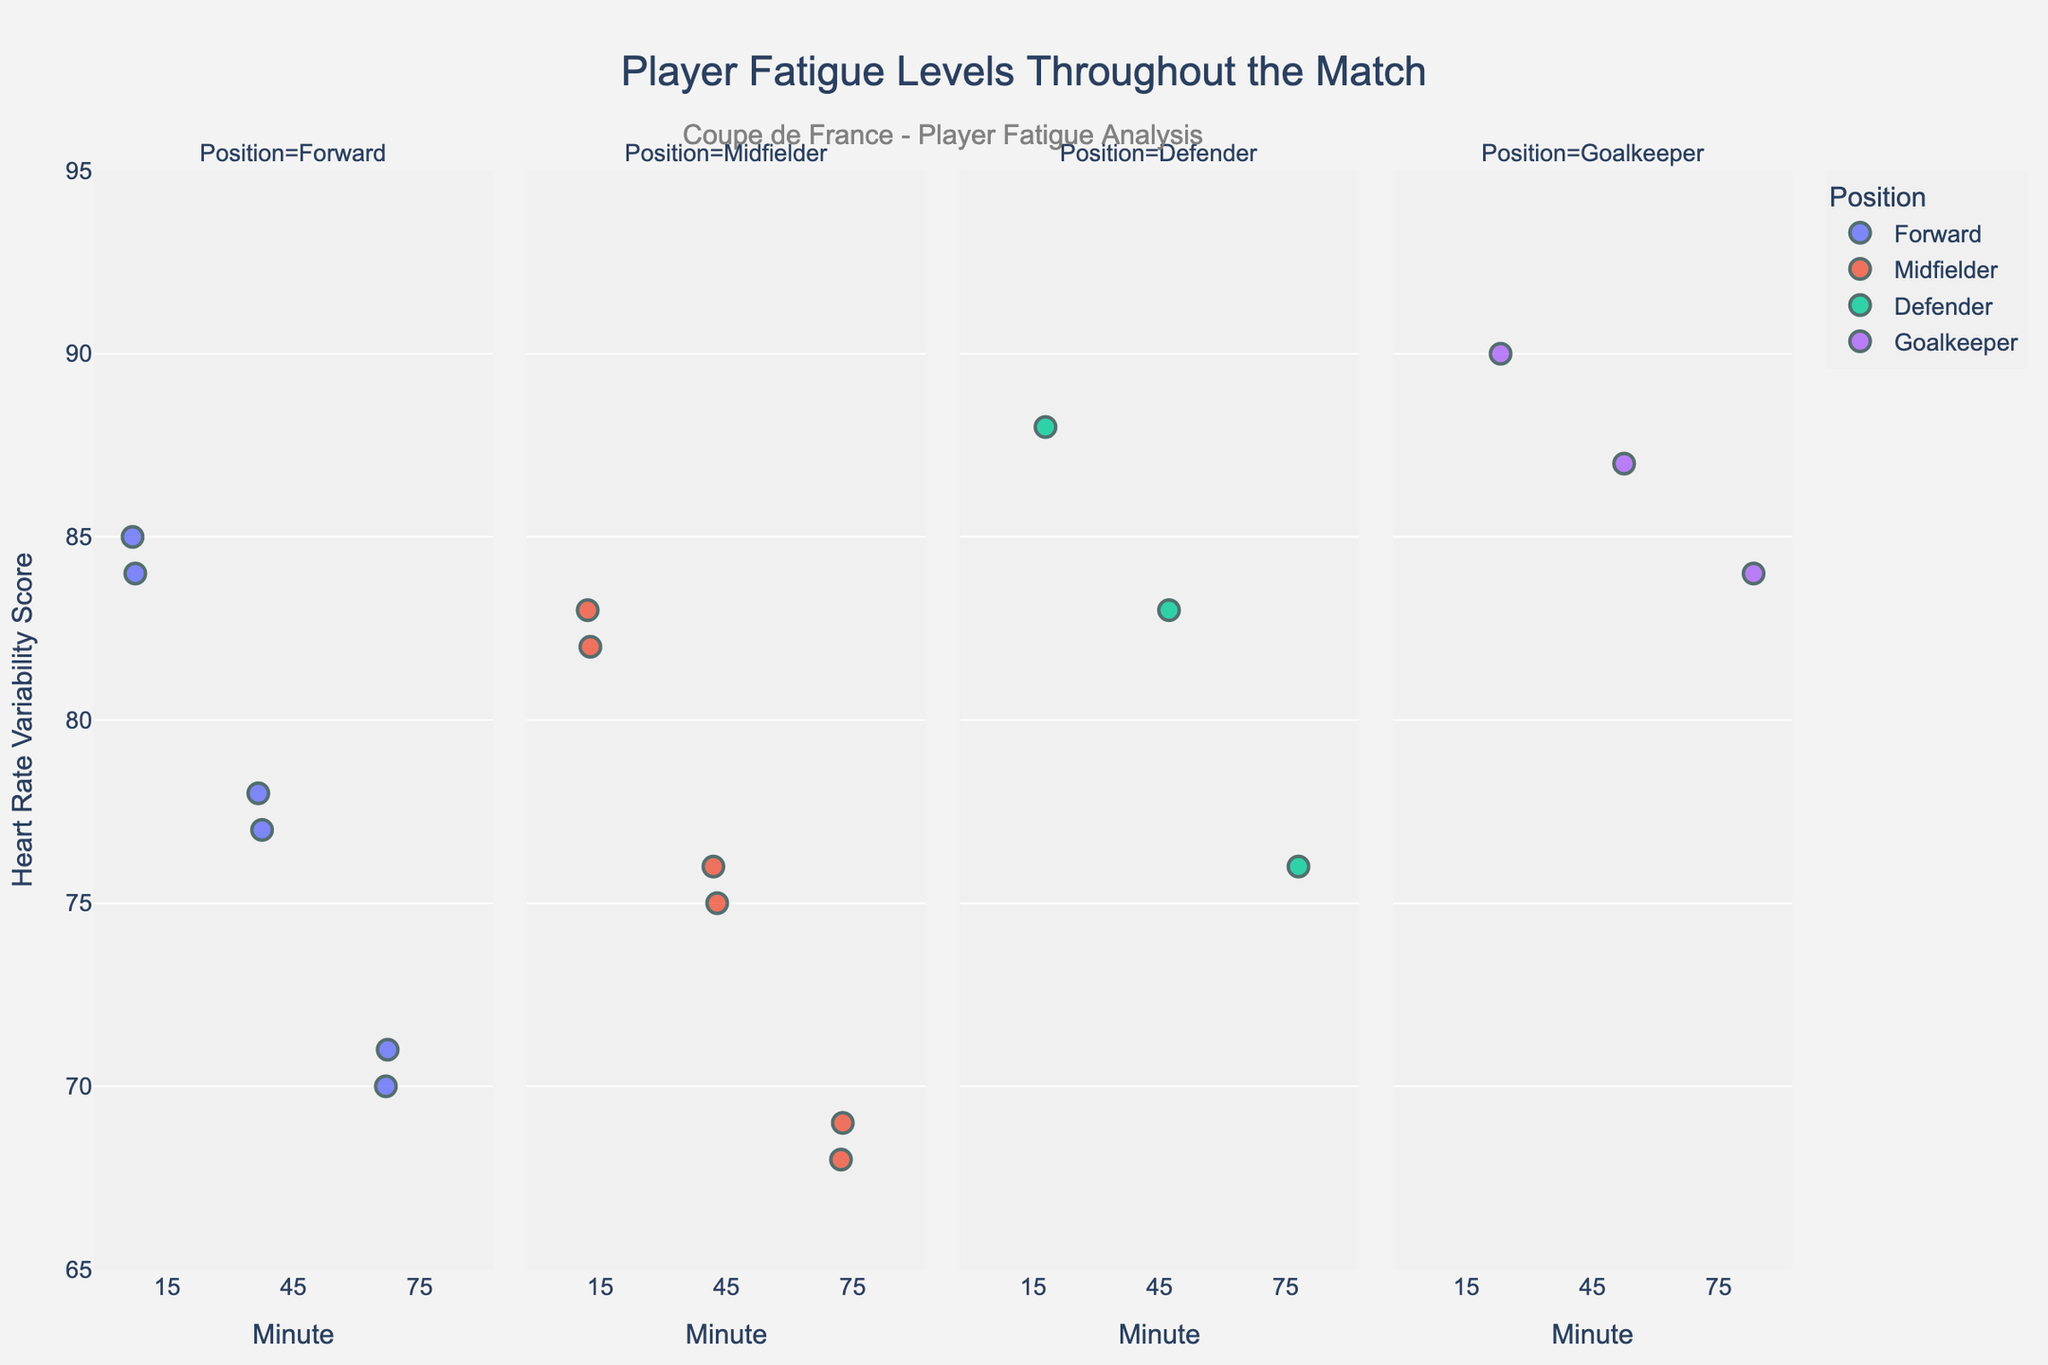How many players were tracked in this analysis? By the different colors in the "Player" hover data, we can count the number of unique players. The players are Kylian Mbappé, Antoine Griezmann, Raphaël Varane, Hugo Lloris, Paul Pogba, and Olivier Giroud.
Answer: 6 Which position shows the highest Heart Rate Variability (HRV) score at the 15th minute? We examine the HRV scores at the 15-minute mark within each position facet. Hugo Lloris, the Goalkeeper, has the highest HRV score of 90.
Answer: Goalkeeper What's the average HRV score of the Midfielders at the 45th minute? We note the HRV scores of Midfielders at the 45th minute: 75 (Antoine Griezmann) and 76 (Paul Pogba). Their average is (75 + 76) / 2 = 75.5.
Answer: 75.5 Which position reflects the most significant decrease in HRV score from the 15th to the 75th minute? We look at the maximum decrease by position: Forwards drop from 85 to 70 (15 points), Midfielders from 83 to 68 (15 points), Defenders from 88 to 76 (12 points), and Goalkeepers from 90 to 84 (6 points).
Answer: Forward and Midfielder How does the Heart Rate Variability (HRV) trend change for Forwards over the match? We observe the HRV scores of Forwards over time: at 15 minutes (85, 84), 45 minutes (78, 77), and 75 minutes (70, 71). Generally, there is a decreasing trend in their HRV scores.
Answer: Decreasing Which player has the most consistent HRV scores throughout the match? Consistency implies the smallest variance. Hugo Lloris (90, 87, 84) shows HRV variations of 3 and 3, less than other players.
Answer: Hugo Lloris What is the median HRV score for Defenders at the 45th minute? With only one Defender, Raphaël Varane, his HRV score of 83 at 45 minutes is the median by default.
Answer: 83 How many unique position groups are represented in the data? By looking at the facets for different positions, we can identify four position groups: Forward, Midfielder, Defender, and Goalkeeper.
Answer: 4 Which position shows the least fatigue (higher HRV score) over the entire match duration? Fatigue indicated by HRV, the Goalkeeper (with scores 90, 87, 84) consistently has the highest HRV scores compared to other positions which show a more significant drop.
Answer: Goalkeeper 